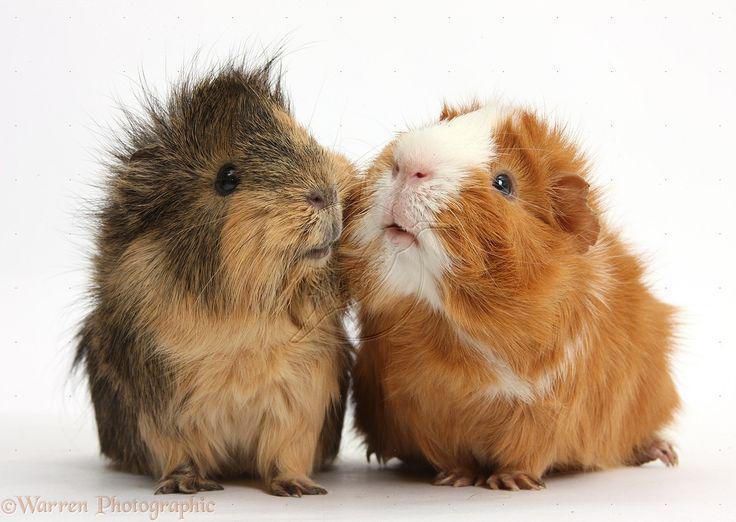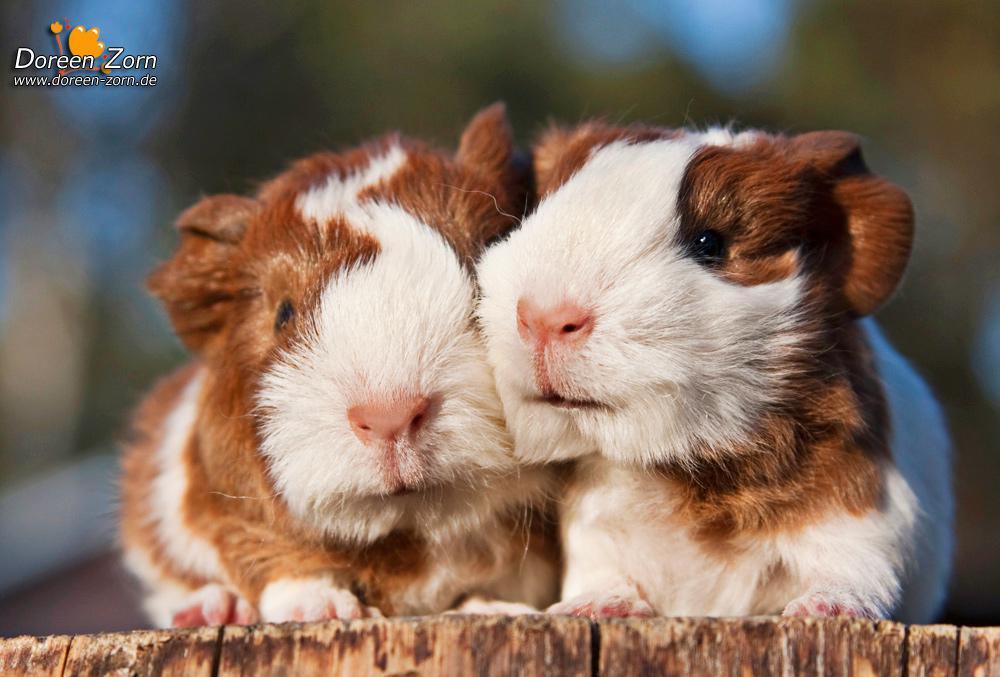The first image is the image on the left, the second image is the image on the right. Assess this claim about the two images: "Two rodents are posing side by side.". Correct or not? Answer yes or no. Yes. The first image is the image on the left, the second image is the image on the right. For the images shown, is this caption "An image features a larger rodent with at least one smaller rodent's head on its back." true? Answer yes or no. No. 